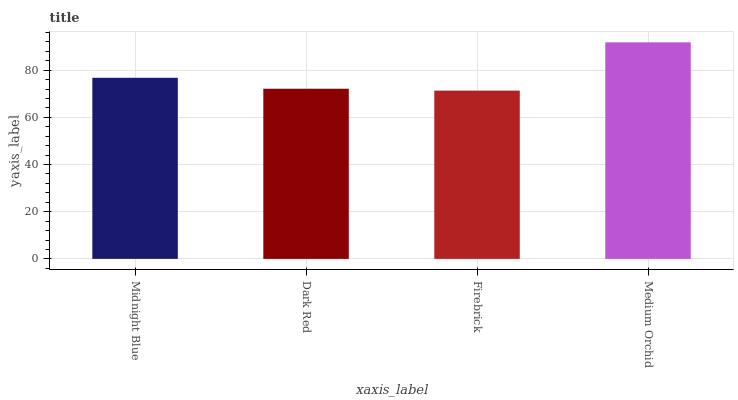Is Firebrick the minimum?
Answer yes or no. Yes. Is Medium Orchid the maximum?
Answer yes or no. Yes. Is Dark Red the minimum?
Answer yes or no. No. Is Dark Red the maximum?
Answer yes or no. No. Is Midnight Blue greater than Dark Red?
Answer yes or no. Yes. Is Dark Red less than Midnight Blue?
Answer yes or no. Yes. Is Dark Red greater than Midnight Blue?
Answer yes or no. No. Is Midnight Blue less than Dark Red?
Answer yes or no. No. Is Midnight Blue the high median?
Answer yes or no. Yes. Is Dark Red the low median?
Answer yes or no. Yes. Is Medium Orchid the high median?
Answer yes or no. No. Is Firebrick the low median?
Answer yes or no. No. 